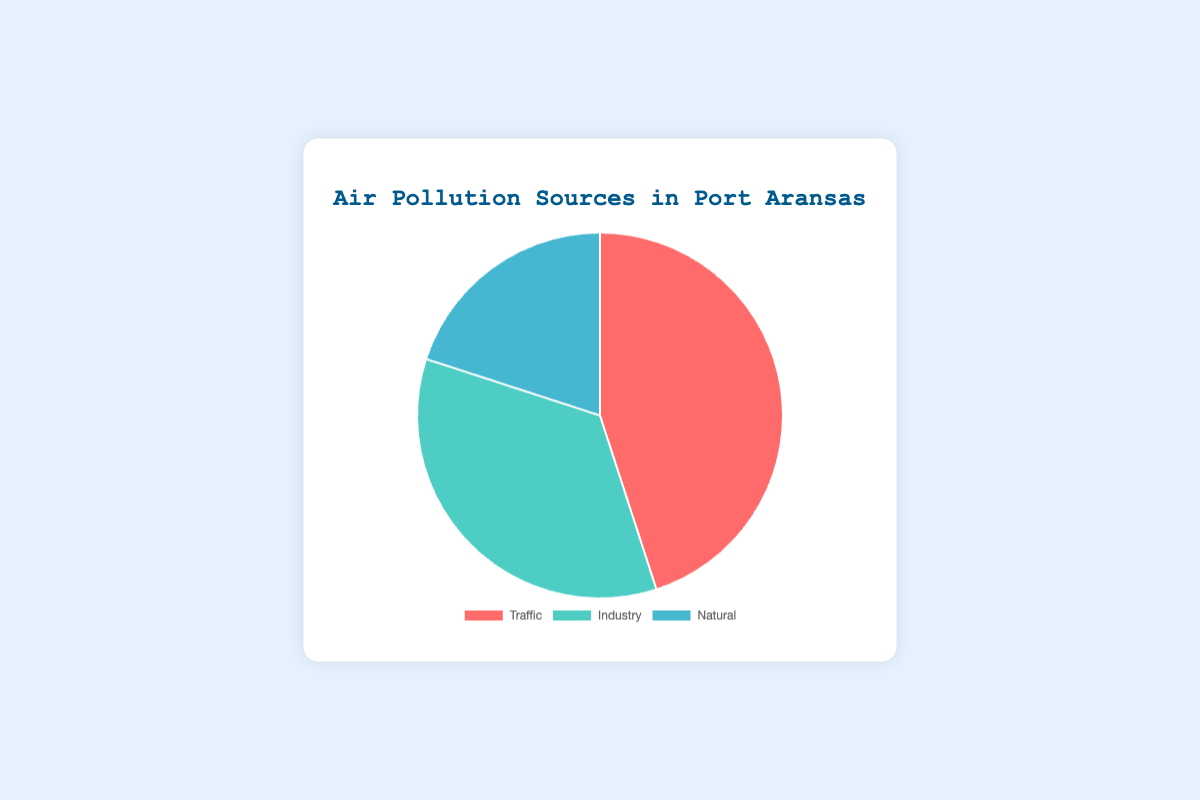what percentage of air pollution does traffic contribute? Traffic contributes 45% to the air pollution, as indicated in the figure.
Answer: 45% Which source contributes the least to air pollution? According to the figure, the natural sources contribute the least at 20%.
Answer: Natural How much more does traffic contribute to air pollution than industry? Traffic contributes 45%, and industry 35%. The difference is 45% - 35% = 10%.
Answer: 10% What is the combined contribution of industry and natural sources to air pollution? The industry contributes 35%, and natural sources contribute 20%. Their combined contribution is 35% + 20% = 55%.
Answer: 55% Which source contributes more to air pollution: industry or natural? The industry contributes 35%, while natural sources contribute 20%. Therefore, the industry contributes more.
Answer: Industry What fraction of the air pollution is caused by natural sources? Natural sources contribute 20%, which is 20/100 or 1/5 of the total air pollution.
Answer: 1/5 If you were to combine traffic and natural sources, what percentage of air pollution would they represent together? Traffic contributes 45% and natural sources contribute 20%. Combined, they represent 45% + 20% = 65%.
Answer: 65% What color represents the industry source in the pie chart? The industry source is represented by the green color in the pie chart.
Answer: Green 